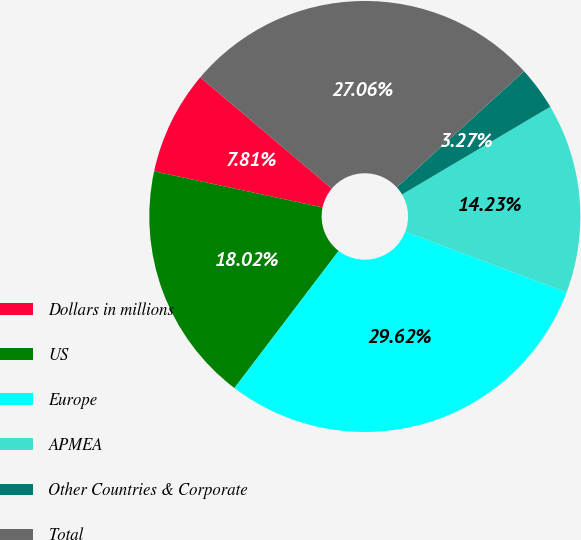Convert chart to OTSL. <chart><loc_0><loc_0><loc_500><loc_500><pie_chart><fcel>Dollars in millions<fcel>US<fcel>Europe<fcel>APMEA<fcel>Other Countries & Corporate<fcel>Total<nl><fcel>7.81%<fcel>18.02%<fcel>29.62%<fcel>14.23%<fcel>3.27%<fcel>27.06%<nl></chart> 